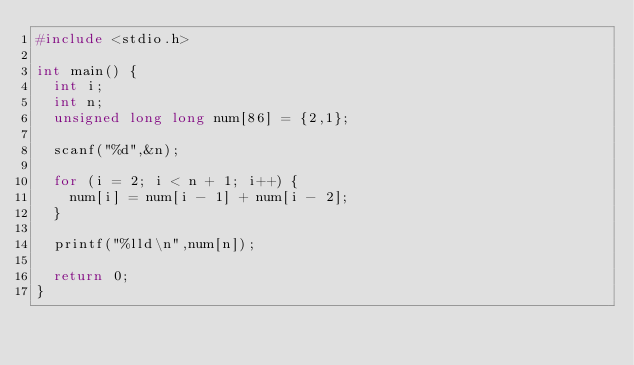Convert code to text. <code><loc_0><loc_0><loc_500><loc_500><_C_>#include <stdio.h>

int main() {
  int i;
  int n;
  unsigned long long num[86] = {2,1};

  scanf("%d",&n);

  for (i = 2; i < n + 1; i++) {
    num[i] = num[i - 1] + num[i - 2];
  }

  printf("%lld\n",num[n]);

  return 0;
}
</code> 